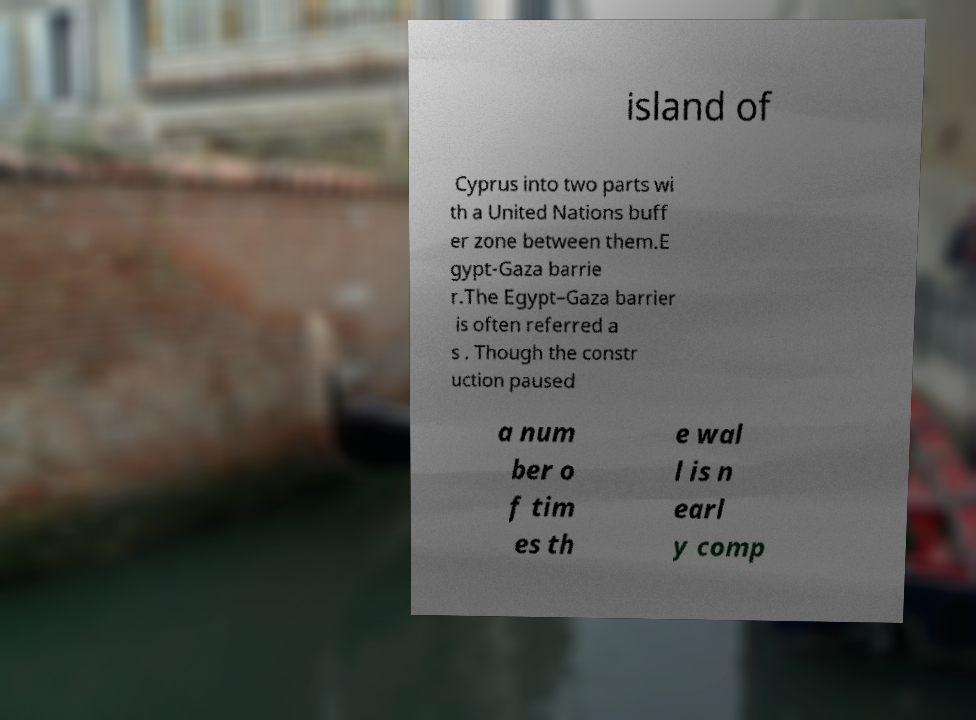There's text embedded in this image that I need extracted. Can you transcribe it verbatim? island of Cyprus into two parts wi th a United Nations buff er zone between them.E gypt-Gaza barrie r.The Egypt–Gaza barrier is often referred a s . Though the constr uction paused a num ber o f tim es th e wal l is n earl y comp 